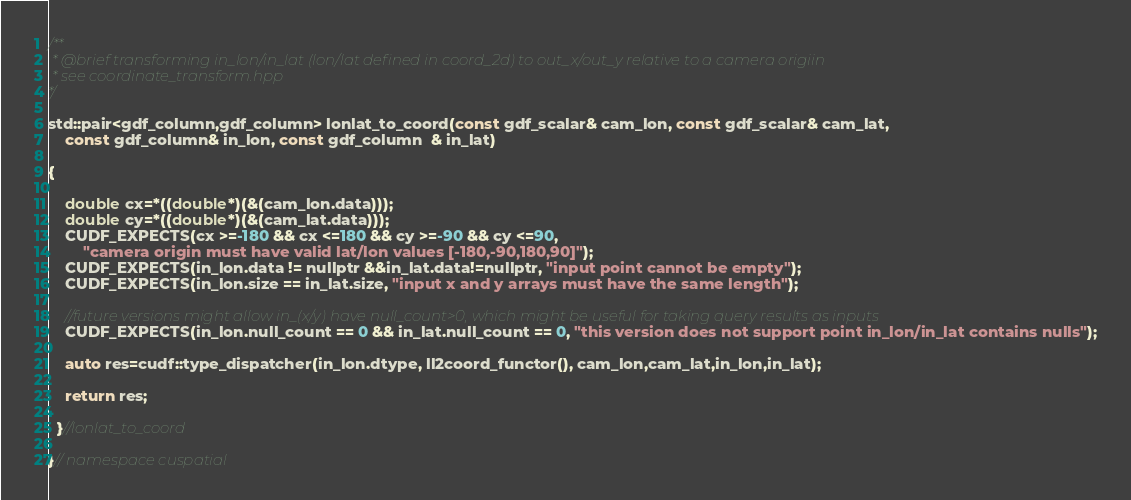<code> <loc_0><loc_0><loc_500><loc_500><_Cuda_>/**
 * @brief transforming in_lon/in_lat (lon/lat defined in coord_2d) to out_x/out_y relative to a camera origiin
 * see coordinate_transform.hpp
*/

std::pair<gdf_column,gdf_column> lonlat_to_coord(const gdf_scalar& cam_lon, const gdf_scalar& cam_lat,
	const gdf_column& in_lon, const gdf_column  & in_lat)

{

    double cx=*((double*)(&(cam_lon.data)));
    double cy=*((double*)(&(cam_lat.data)));
    CUDF_EXPECTS(cx >=-180 && cx <=180 && cy >=-90 && cy <=90,
    	"camera origin must have valid lat/lon values [-180,-90,180,90]");
    CUDF_EXPECTS(in_lon.data != nullptr &&in_lat.data!=nullptr, "input point cannot be empty");
    CUDF_EXPECTS(in_lon.size == in_lat.size, "input x and y arrays must have the same length");

    //future versions might allow in_(x/y) have null_count>0, which might be useful for taking query results as inputs
    CUDF_EXPECTS(in_lon.null_count == 0 && in_lat.null_count == 0, "this version does not support point in_lon/in_lat contains nulls");

    auto res=cudf::type_dispatcher(in_lon.dtype, ll2coord_functor(), cam_lon,cam_lat,in_lon,in_lat);

    return res;

  }//lonlat_to_coord

}// namespace cuspatial
</code> 